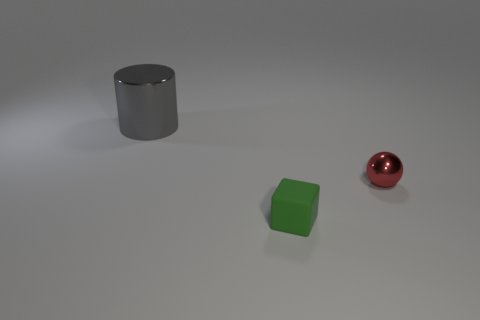Add 1 big gray shiny balls. How many objects exist? 4 Subtract all cylinders. How many objects are left? 2 Subtract 0 yellow spheres. How many objects are left? 3 Subtract all tiny red rubber cylinders. Subtract all gray metallic cylinders. How many objects are left? 2 Add 2 red metallic spheres. How many red metallic spheres are left? 3 Add 2 gray things. How many gray things exist? 3 